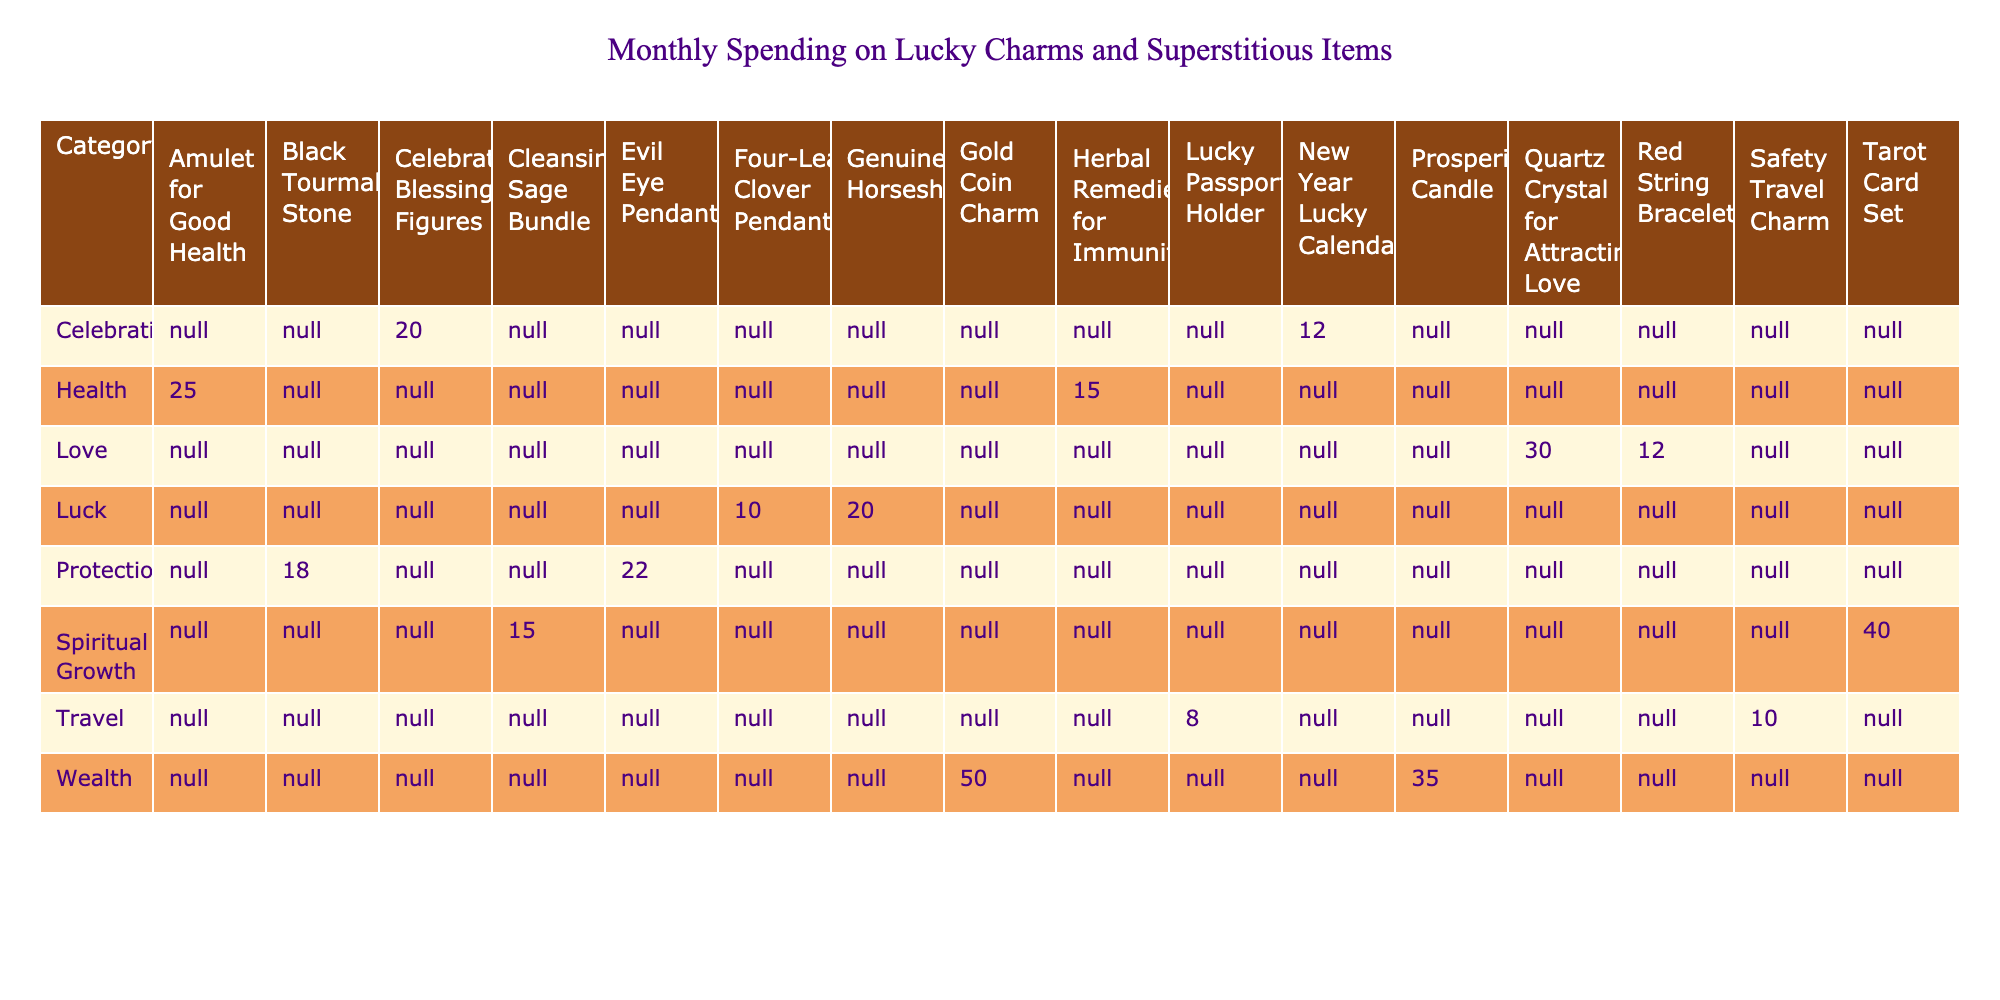What is the total monthly spending on Protection items? The table shows two items under the Protection category: Black Tourmaline Stone ($18) and Evil Eye Pendant ($22). To find the total, we add these values: 18 + 22 = 40.
Answer: 40 Which Love item has the highest monthly spending? In the Love category, there are two items listed: Quartz Crystal for Attracting Love ($30) and Red String Bracelet ($12). The highest spending is on the Quartz Crystal for Attracting Love at $30.
Answer: Quartz Crystal for Attracting Love Is the total spending on Wealth items greater than the total spending on Health items? The Wealth category has two items: Gold Coin Charm ($50) and Prosperity Candle ($35), giving a total of 50 + 35 = 85. The Health category includes an Amulet for Good Health ($25) and Herbal Remedies for Immunity ($15), totaling 25 + 15 = 40. Since 85 is greater than 40, the answer is yes.
Answer: Yes What is the average monthly spending on items in the Travel category? The Travel category has two items: Safety Travel Charm ($10) and Lucky Passport Holder ($8). To find the average, we first sum the spending: 10 + 8 = 18. There are 2 items, so we divide by 2: 18 / 2 = 9.
Answer: 9 How much is spent on spiritual growth items compared to the combined spending on the Love and Luck categories? The Spiritual Growth category has two items: Cleansing Sage Bundle ($15) and Tarot Card Set ($40), totaling 15 + 40 = 55. The Love category totals 30 + 12 = 42, and the Luck category totals 10 + 20 = 30. Combining Love and Luck gives us 42 + 30 = 72. Since 55 is less than 72, the answer is no.
Answer: No 